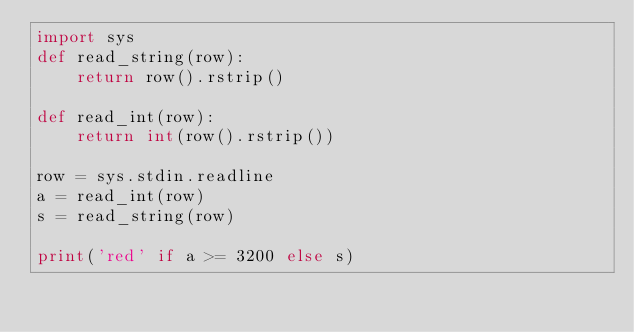<code> <loc_0><loc_0><loc_500><loc_500><_Python_>import sys
def read_string(row):
    return row().rstrip()

def read_int(row):
    return int(row().rstrip())
  
row = sys.stdin.readline
a = read_int(row)
s = read_string(row)

print('red' if a >= 3200 else s)</code> 